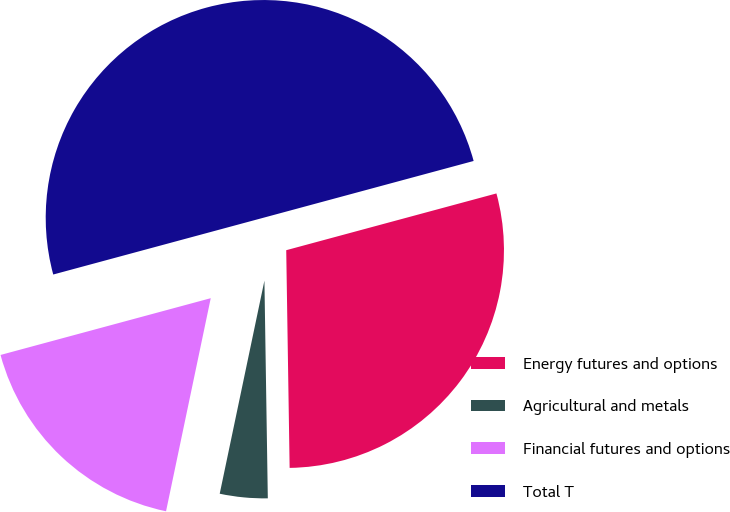<chart> <loc_0><loc_0><loc_500><loc_500><pie_chart><fcel>Energy futures and options<fcel>Agricultural and metals<fcel>Financial futures and options<fcel>Total T<nl><fcel>28.95%<fcel>3.54%<fcel>17.51%<fcel>50.0%<nl></chart> 